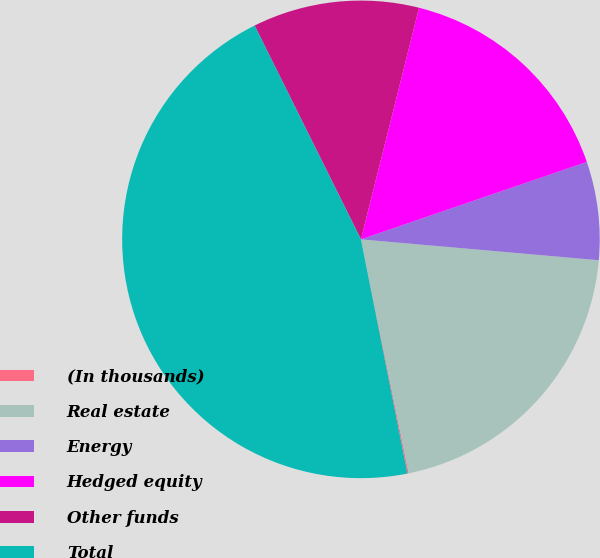Convert chart to OTSL. <chart><loc_0><loc_0><loc_500><loc_500><pie_chart><fcel>(In thousands)<fcel>Real estate<fcel>Energy<fcel>Hedged equity<fcel>Other funds<fcel>Total<nl><fcel>0.09%<fcel>20.4%<fcel>6.65%<fcel>15.83%<fcel>11.26%<fcel>45.78%<nl></chart> 